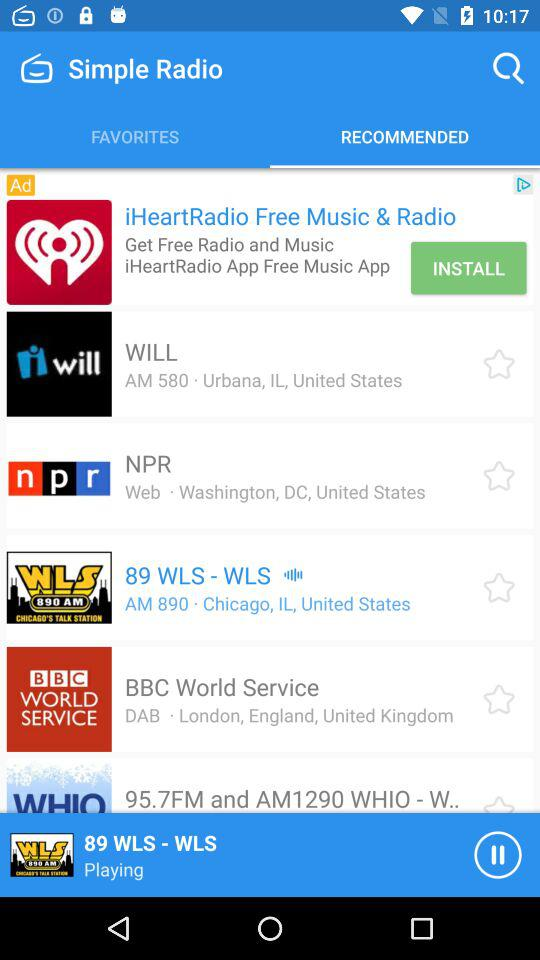What is the location of "WILL"? The location is Urbana, Illinois, United States. 